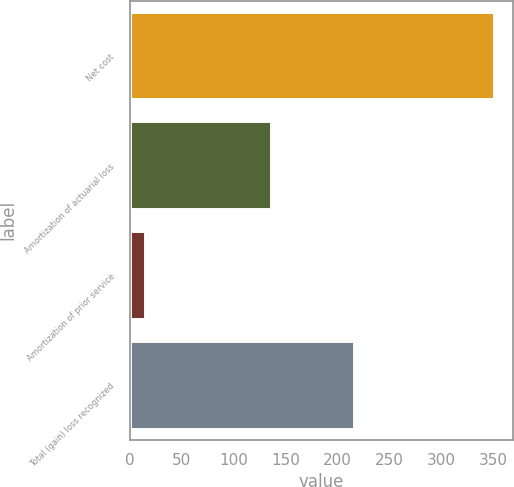Convert chart to OTSL. <chart><loc_0><loc_0><loc_500><loc_500><bar_chart><fcel>Net cost<fcel>Amortization of actuarial loss<fcel>Amortization of prior service<fcel>Total (gain) loss recognized<nl><fcel>351<fcel>136<fcel>15<fcel>216<nl></chart> 